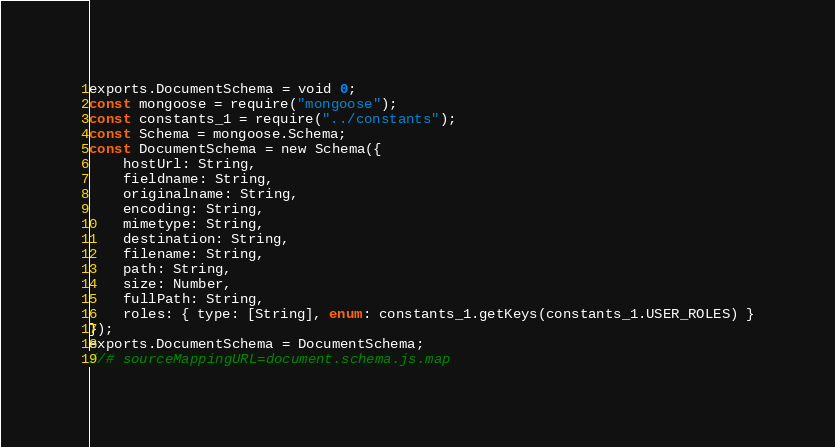<code> <loc_0><loc_0><loc_500><loc_500><_JavaScript_>exports.DocumentSchema = void 0;
const mongoose = require("mongoose");
const constants_1 = require("../constants");
const Schema = mongoose.Schema;
const DocumentSchema = new Schema({
    hostUrl: String,
    fieldname: String,
    originalname: String,
    encoding: String,
    mimetype: String,
    destination: String,
    filename: String,
    path: String,
    size: Number,
    fullPath: String,
    roles: { type: [String], enum: constants_1.getKeys(constants_1.USER_ROLES) }
});
exports.DocumentSchema = DocumentSchema;
//# sourceMappingURL=document.schema.js.map</code> 